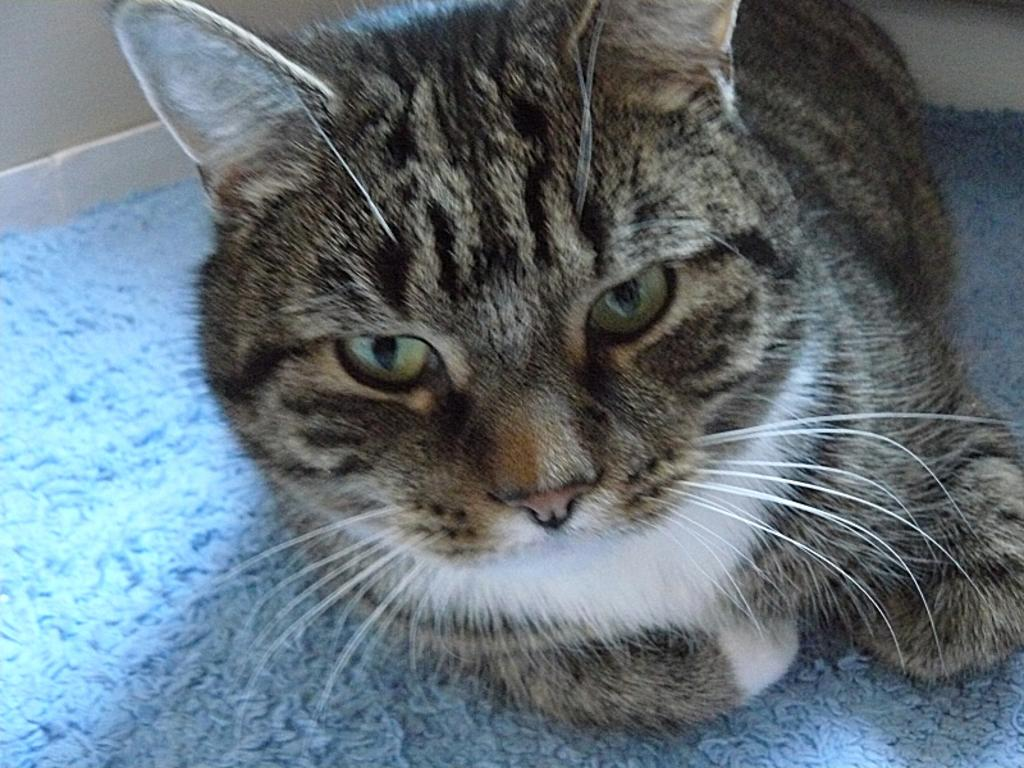What type of animal is in the image? There is a cat in the image. Where is the cat located? The cat is on a floor mat. Can you describe the cat's color pattern? The cat has a white, black, and light brown color pattern. What type of cheese is the cat eating in the image? There is no cheese present in the image; the cat is not eating anything. 